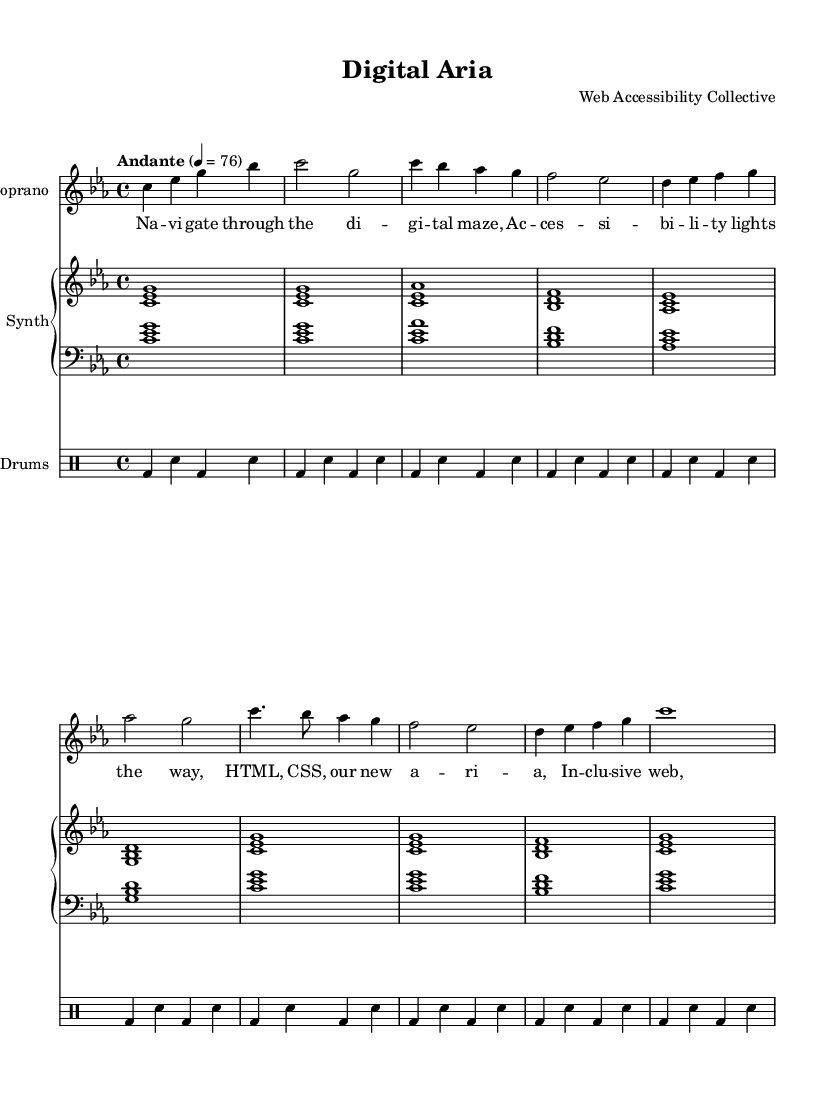What is the key signature of this music? The key signature is indicated at the beginning of the staff, showing C minor which has three flats (B flat, E flat, and A flat).
Answer: C minor What is the time signature of the piece? The time signature is displayed as a fraction at the start of the staff, indicating that there are four beats in each measure and a quarter note gets one beat, hence 4/4.
Answer: 4/4 What is the tempo marking for this composition? The tempo marking is written as "Andante" above the staff, suggesting a moderate pace, often interpreted as walking speed, typically around 76 beats per minute.
Answer: Andante How many measures are in the soprano part? By counting the number of grouped notes and the bar lines in the soprano part, we find there are eight measures total in the provided excerpt.
Answer: Eight What do the electronic drums and synthesizer provide for the overall piece? The electronic drums add a rhythmic foundation with a steady beat, while the synthesizer contributes harmonic support and texture, enhancing the fusion nature of this opera piece.
Answer: Harmonic and rhythmic support Describe the thematic content of the chorus lyrics. The chorus lyrics refer to technology used for web development, representing the blend of traditional and modern elements in the opera with expressions like "HTML, CSS" in the lyrics, connecting digital concepts to operatic themes.
Answer: Web technology themes 